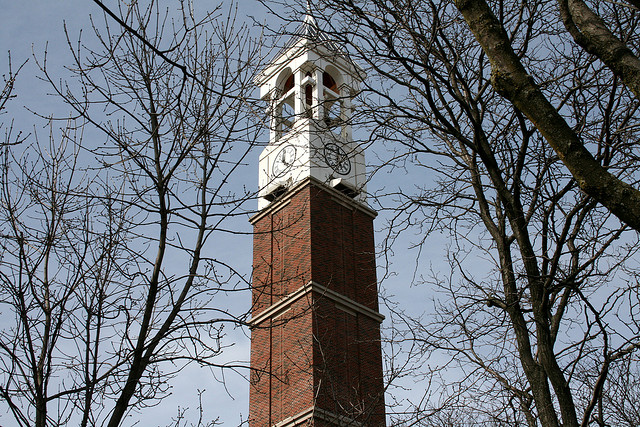<image>Was this picture taken in July? It is ambiguous if the picture was taken in July. Was this picture taken in July? I am not sure if the picture was taken in July. It can be both yes or no. 